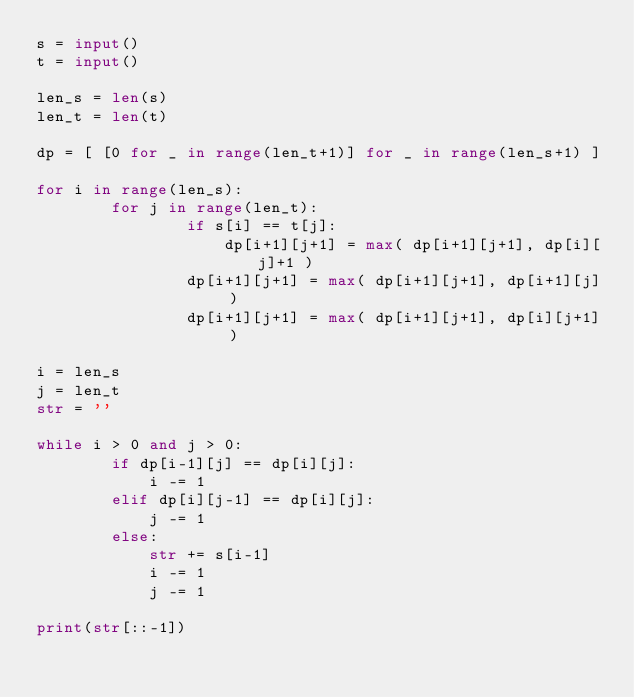<code> <loc_0><loc_0><loc_500><loc_500><_Python_>s = input()
t = input()

len_s = len(s)
len_t = len(t)

dp = [ [0 for _ in range(len_t+1)] for _ in range(len_s+1) ]

for i in range(len_s):
        for j in range(len_t):
                if s[i] == t[j]:
                    dp[i+1][j+1] = max( dp[i+1][j+1], dp[i][j]+1 )
                dp[i+1][j+1] = max( dp[i+1][j+1], dp[i+1][j] )
                dp[i+1][j+1] = max( dp[i+1][j+1], dp[i][j+1] )

i = len_s
j = len_t
str = ''

while i > 0 and j > 0:
        if dp[i-1][j] == dp[i][j]:
            i -= 1
        elif dp[i][j-1] == dp[i][j]:
            j -= 1
        else:
            str += s[i-1]
            i -= 1
            j -= 1
            
print(str[::-1])</code> 